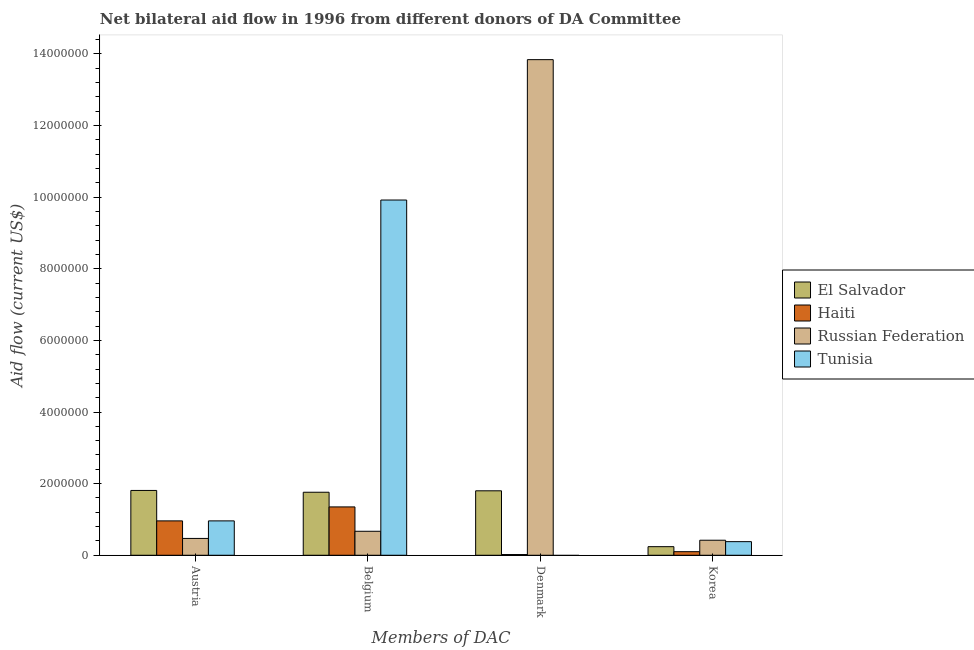What is the amount of aid given by denmark in Haiti?
Your answer should be compact. 2.00e+04. Across all countries, what is the maximum amount of aid given by austria?
Ensure brevity in your answer.  1.81e+06. Across all countries, what is the minimum amount of aid given by belgium?
Offer a very short reply. 6.70e+05. In which country was the amount of aid given by denmark maximum?
Keep it short and to the point. Russian Federation. What is the total amount of aid given by belgium in the graph?
Ensure brevity in your answer.  1.37e+07. What is the difference between the amount of aid given by austria in Haiti and that in El Salvador?
Ensure brevity in your answer.  -8.50e+05. What is the difference between the amount of aid given by korea in Russian Federation and the amount of aid given by austria in El Salvador?
Your response must be concise. -1.39e+06. What is the average amount of aid given by korea per country?
Give a very brief answer. 2.85e+05. What is the difference between the amount of aid given by korea and amount of aid given by austria in El Salvador?
Provide a short and direct response. -1.57e+06. In how many countries, is the amount of aid given by austria greater than 11600000 US$?
Give a very brief answer. 0. What is the ratio of the amount of aid given by belgium in Russian Federation to that in El Salvador?
Keep it short and to the point. 0.38. Is the amount of aid given by austria in El Salvador less than that in Haiti?
Provide a succinct answer. No. Is the difference between the amount of aid given by belgium in Haiti and El Salvador greater than the difference between the amount of aid given by denmark in Haiti and El Salvador?
Your answer should be very brief. Yes. What is the difference between the highest and the second highest amount of aid given by denmark?
Make the answer very short. 1.20e+07. What is the difference between the highest and the lowest amount of aid given by denmark?
Offer a terse response. 1.38e+07. In how many countries, is the amount of aid given by korea greater than the average amount of aid given by korea taken over all countries?
Provide a succinct answer. 2. Is it the case that in every country, the sum of the amount of aid given by denmark and amount of aid given by austria is greater than the sum of amount of aid given by korea and amount of aid given by belgium?
Provide a short and direct response. No. Is it the case that in every country, the sum of the amount of aid given by austria and amount of aid given by belgium is greater than the amount of aid given by denmark?
Your answer should be compact. No. What is the difference between two consecutive major ticks on the Y-axis?
Offer a terse response. 2.00e+06. Does the graph contain any zero values?
Make the answer very short. Yes. What is the title of the graph?
Your answer should be compact. Net bilateral aid flow in 1996 from different donors of DA Committee. Does "Kiribati" appear as one of the legend labels in the graph?
Make the answer very short. No. What is the label or title of the X-axis?
Your response must be concise. Members of DAC. What is the Aid flow (current US$) of El Salvador in Austria?
Provide a short and direct response. 1.81e+06. What is the Aid flow (current US$) in Haiti in Austria?
Offer a very short reply. 9.60e+05. What is the Aid flow (current US$) of Russian Federation in Austria?
Provide a short and direct response. 4.70e+05. What is the Aid flow (current US$) in Tunisia in Austria?
Your answer should be compact. 9.60e+05. What is the Aid flow (current US$) in El Salvador in Belgium?
Provide a short and direct response. 1.76e+06. What is the Aid flow (current US$) in Haiti in Belgium?
Offer a very short reply. 1.35e+06. What is the Aid flow (current US$) of Russian Federation in Belgium?
Offer a terse response. 6.70e+05. What is the Aid flow (current US$) in Tunisia in Belgium?
Your answer should be very brief. 9.92e+06. What is the Aid flow (current US$) of El Salvador in Denmark?
Make the answer very short. 1.80e+06. What is the Aid flow (current US$) of Russian Federation in Denmark?
Make the answer very short. 1.38e+07. What is the Aid flow (current US$) in Russian Federation in Korea?
Offer a terse response. 4.20e+05. What is the Aid flow (current US$) of Tunisia in Korea?
Offer a very short reply. 3.80e+05. Across all Members of DAC, what is the maximum Aid flow (current US$) of El Salvador?
Your answer should be very brief. 1.81e+06. Across all Members of DAC, what is the maximum Aid flow (current US$) in Haiti?
Offer a very short reply. 1.35e+06. Across all Members of DAC, what is the maximum Aid flow (current US$) of Russian Federation?
Make the answer very short. 1.38e+07. Across all Members of DAC, what is the maximum Aid flow (current US$) in Tunisia?
Make the answer very short. 9.92e+06. What is the total Aid flow (current US$) of El Salvador in the graph?
Provide a short and direct response. 5.61e+06. What is the total Aid flow (current US$) in Haiti in the graph?
Keep it short and to the point. 2.43e+06. What is the total Aid flow (current US$) of Russian Federation in the graph?
Provide a short and direct response. 1.54e+07. What is the total Aid flow (current US$) in Tunisia in the graph?
Provide a succinct answer. 1.13e+07. What is the difference between the Aid flow (current US$) in El Salvador in Austria and that in Belgium?
Provide a short and direct response. 5.00e+04. What is the difference between the Aid flow (current US$) of Haiti in Austria and that in Belgium?
Make the answer very short. -3.90e+05. What is the difference between the Aid flow (current US$) in Tunisia in Austria and that in Belgium?
Give a very brief answer. -8.96e+06. What is the difference between the Aid flow (current US$) in El Salvador in Austria and that in Denmark?
Keep it short and to the point. 10000. What is the difference between the Aid flow (current US$) of Haiti in Austria and that in Denmark?
Provide a succinct answer. 9.40e+05. What is the difference between the Aid flow (current US$) in Russian Federation in Austria and that in Denmark?
Your response must be concise. -1.34e+07. What is the difference between the Aid flow (current US$) of El Salvador in Austria and that in Korea?
Give a very brief answer. 1.57e+06. What is the difference between the Aid flow (current US$) in Haiti in Austria and that in Korea?
Provide a short and direct response. 8.60e+05. What is the difference between the Aid flow (current US$) in Tunisia in Austria and that in Korea?
Your response must be concise. 5.80e+05. What is the difference between the Aid flow (current US$) in Haiti in Belgium and that in Denmark?
Offer a very short reply. 1.33e+06. What is the difference between the Aid flow (current US$) of Russian Federation in Belgium and that in Denmark?
Provide a succinct answer. -1.32e+07. What is the difference between the Aid flow (current US$) in El Salvador in Belgium and that in Korea?
Your answer should be very brief. 1.52e+06. What is the difference between the Aid flow (current US$) in Haiti in Belgium and that in Korea?
Your answer should be compact. 1.25e+06. What is the difference between the Aid flow (current US$) of Russian Federation in Belgium and that in Korea?
Your answer should be compact. 2.50e+05. What is the difference between the Aid flow (current US$) in Tunisia in Belgium and that in Korea?
Keep it short and to the point. 9.54e+06. What is the difference between the Aid flow (current US$) of El Salvador in Denmark and that in Korea?
Keep it short and to the point. 1.56e+06. What is the difference between the Aid flow (current US$) in Haiti in Denmark and that in Korea?
Your answer should be compact. -8.00e+04. What is the difference between the Aid flow (current US$) in Russian Federation in Denmark and that in Korea?
Give a very brief answer. 1.34e+07. What is the difference between the Aid flow (current US$) in El Salvador in Austria and the Aid flow (current US$) in Haiti in Belgium?
Provide a short and direct response. 4.60e+05. What is the difference between the Aid flow (current US$) of El Salvador in Austria and the Aid flow (current US$) of Russian Federation in Belgium?
Your answer should be compact. 1.14e+06. What is the difference between the Aid flow (current US$) of El Salvador in Austria and the Aid flow (current US$) of Tunisia in Belgium?
Provide a short and direct response. -8.11e+06. What is the difference between the Aid flow (current US$) of Haiti in Austria and the Aid flow (current US$) of Tunisia in Belgium?
Ensure brevity in your answer.  -8.96e+06. What is the difference between the Aid flow (current US$) in Russian Federation in Austria and the Aid flow (current US$) in Tunisia in Belgium?
Your answer should be very brief. -9.45e+06. What is the difference between the Aid flow (current US$) in El Salvador in Austria and the Aid flow (current US$) in Haiti in Denmark?
Offer a very short reply. 1.79e+06. What is the difference between the Aid flow (current US$) in El Salvador in Austria and the Aid flow (current US$) in Russian Federation in Denmark?
Provide a short and direct response. -1.20e+07. What is the difference between the Aid flow (current US$) in Haiti in Austria and the Aid flow (current US$) in Russian Federation in Denmark?
Your answer should be compact. -1.29e+07. What is the difference between the Aid flow (current US$) in El Salvador in Austria and the Aid flow (current US$) in Haiti in Korea?
Your answer should be compact. 1.71e+06. What is the difference between the Aid flow (current US$) of El Salvador in Austria and the Aid flow (current US$) of Russian Federation in Korea?
Your answer should be compact. 1.39e+06. What is the difference between the Aid flow (current US$) of El Salvador in Austria and the Aid flow (current US$) of Tunisia in Korea?
Your answer should be very brief. 1.43e+06. What is the difference between the Aid flow (current US$) of Haiti in Austria and the Aid flow (current US$) of Russian Federation in Korea?
Give a very brief answer. 5.40e+05. What is the difference between the Aid flow (current US$) in Haiti in Austria and the Aid flow (current US$) in Tunisia in Korea?
Ensure brevity in your answer.  5.80e+05. What is the difference between the Aid flow (current US$) of El Salvador in Belgium and the Aid flow (current US$) of Haiti in Denmark?
Give a very brief answer. 1.74e+06. What is the difference between the Aid flow (current US$) in El Salvador in Belgium and the Aid flow (current US$) in Russian Federation in Denmark?
Keep it short and to the point. -1.21e+07. What is the difference between the Aid flow (current US$) of Haiti in Belgium and the Aid flow (current US$) of Russian Federation in Denmark?
Make the answer very short. -1.25e+07. What is the difference between the Aid flow (current US$) in El Salvador in Belgium and the Aid flow (current US$) in Haiti in Korea?
Offer a very short reply. 1.66e+06. What is the difference between the Aid flow (current US$) of El Salvador in Belgium and the Aid flow (current US$) of Russian Federation in Korea?
Your response must be concise. 1.34e+06. What is the difference between the Aid flow (current US$) in El Salvador in Belgium and the Aid flow (current US$) in Tunisia in Korea?
Your answer should be very brief. 1.38e+06. What is the difference between the Aid flow (current US$) in Haiti in Belgium and the Aid flow (current US$) in Russian Federation in Korea?
Keep it short and to the point. 9.30e+05. What is the difference between the Aid flow (current US$) of Haiti in Belgium and the Aid flow (current US$) of Tunisia in Korea?
Keep it short and to the point. 9.70e+05. What is the difference between the Aid flow (current US$) in El Salvador in Denmark and the Aid flow (current US$) in Haiti in Korea?
Ensure brevity in your answer.  1.70e+06. What is the difference between the Aid flow (current US$) in El Salvador in Denmark and the Aid flow (current US$) in Russian Federation in Korea?
Your answer should be compact. 1.38e+06. What is the difference between the Aid flow (current US$) in El Salvador in Denmark and the Aid flow (current US$) in Tunisia in Korea?
Your response must be concise. 1.42e+06. What is the difference between the Aid flow (current US$) of Haiti in Denmark and the Aid flow (current US$) of Russian Federation in Korea?
Provide a succinct answer. -4.00e+05. What is the difference between the Aid flow (current US$) in Haiti in Denmark and the Aid flow (current US$) in Tunisia in Korea?
Make the answer very short. -3.60e+05. What is the difference between the Aid flow (current US$) in Russian Federation in Denmark and the Aid flow (current US$) in Tunisia in Korea?
Provide a short and direct response. 1.35e+07. What is the average Aid flow (current US$) in El Salvador per Members of DAC?
Make the answer very short. 1.40e+06. What is the average Aid flow (current US$) of Haiti per Members of DAC?
Make the answer very short. 6.08e+05. What is the average Aid flow (current US$) in Russian Federation per Members of DAC?
Provide a short and direct response. 3.85e+06. What is the average Aid flow (current US$) of Tunisia per Members of DAC?
Your answer should be very brief. 2.82e+06. What is the difference between the Aid flow (current US$) in El Salvador and Aid flow (current US$) in Haiti in Austria?
Your response must be concise. 8.50e+05. What is the difference between the Aid flow (current US$) in El Salvador and Aid flow (current US$) in Russian Federation in Austria?
Offer a very short reply. 1.34e+06. What is the difference between the Aid flow (current US$) of El Salvador and Aid flow (current US$) of Tunisia in Austria?
Give a very brief answer. 8.50e+05. What is the difference between the Aid flow (current US$) of Haiti and Aid flow (current US$) of Tunisia in Austria?
Provide a short and direct response. 0. What is the difference between the Aid flow (current US$) of Russian Federation and Aid flow (current US$) of Tunisia in Austria?
Your response must be concise. -4.90e+05. What is the difference between the Aid flow (current US$) of El Salvador and Aid flow (current US$) of Haiti in Belgium?
Offer a very short reply. 4.10e+05. What is the difference between the Aid flow (current US$) in El Salvador and Aid flow (current US$) in Russian Federation in Belgium?
Provide a succinct answer. 1.09e+06. What is the difference between the Aid flow (current US$) in El Salvador and Aid flow (current US$) in Tunisia in Belgium?
Offer a terse response. -8.16e+06. What is the difference between the Aid flow (current US$) in Haiti and Aid flow (current US$) in Russian Federation in Belgium?
Give a very brief answer. 6.80e+05. What is the difference between the Aid flow (current US$) of Haiti and Aid flow (current US$) of Tunisia in Belgium?
Provide a short and direct response. -8.57e+06. What is the difference between the Aid flow (current US$) in Russian Federation and Aid flow (current US$) in Tunisia in Belgium?
Offer a very short reply. -9.25e+06. What is the difference between the Aid flow (current US$) of El Salvador and Aid flow (current US$) of Haiti in Denmark?
Provide a succinct answer. 1.78e+06. What is the difference between the Aid flow (current US$) in El Salvador and Aid flow (current US$) in Russian Federation in Denmark?
Provide a short and direct response. -1.20e+07. What is the difference between the Aid flow (current US$) in Haiti and Aid flow (current US$) in Russian Federation in Denmark?
Your answer should be compact. -1.38e+07. What is the difference between the Aid flow (current US$) of El Salvador and Aid flow (current US$) of Russian Federation in Korea?
Offer a very short reply. -1.80e+05. What is the difference between the Aid flow (current US$) of Haiti and Aid flow (current US$) of Russian Federation in Korea?
Give a very brief answer. -3.20e+05. What is the difference between the Aid flow (current US$) in Haiti and Aid flow (current US$) in Tunisia in Korea?
Provide a succinct answer. -2.80e+05. What is the ratio of the Aid flow (current US$) of El Salvador in Austria to that in Belgium?
Provide a succinct answer. 1.03. What is the ratio of the Aid flow (current US$) of Haiti in Austria to that in Belgium?
Provide a succinct answer. 0.71. What is the ratio of the Aid flow (current US$) of Russian Federation in Austria to that in Belgium?
Give a very brief answer. 0.7. What is the ratio of the Aid flow (current US$) in Tunisia in Austria to that in Belgium?
Ensure brevity in your answer.  0.1. What is the ratio of the Aid flow (current US$) of El Salvador in Austria to that in Denmark?
Your answer should be compact. 1.01. What is the ratio of the Aid flow (current US$) of Haiti in Austria to that in Denmark?
Offer a terse response. 48. What is the ratio of the Aid flow (current US$) of Russian Federation in Austria to that in Denmark?
Offer a terse response. 0.03. What is the ratio of the Aid flow (current US$) in El Salvador in Austria to that in Korea?
Keep it short and to the point. 7.54. What is the ratio of the Aid flow (current US$) in Russian Federation in Austria to that in Korea?
Your response must be concise. 1.12. What is the ratio of the Aid flow (current US$) in Tunisia in Austria to that in Korea?
Your response must be concise. 2.53. What is the ratio of the Aid flow (current US$) of El Salvador in Belgium to that in Denmark?
Your answer should be compact. 0.98. What is the ratio of the Aid flow (current US$) in Haiti in Belgium to that in Denmark?
Your response must be concise. 67.5. What is the ratio of the Aid flow (current US$) in Russian Federation in Belgium to that in Denmark?
Give a very brief answer. 0.05. What is the ratio of the Aid flow (current US$) of El Salvador in Belgium to that in Korea?
Give a very brief answer. 7.33. What is the ratio of the Aid flow (current US$) in Haiti in Belgium to that in Korea?
Your answer should be very brief. 13.5. What is the ratio of the Aid flow (current US$) of Russian Federation in Belgium to that in Korea?
Your response must be concise. 1.6. What is the ratio of the Aid flow (current US$) in Tunisia in Belgium to that in Korea?
Give a very brief answer. 26.11. What is the ratio of the Aid flow (current US$) of El Salvador in Denmark to that in Korea?
Ensure brevity in your answer.  7.5. What is the ratio of the Aid flow (current US$) of Russian Federation in Denmark to that in Korea?
Provide a succinct answer. 32.95. What is the difference between the highest and the second highest Aid flow (current US$) of Haiti?
Offer a terse response. 3.90e+05. What is the difference between the highest and the second highest Aid flow (current US$) in Russian Federation?
Keep it short and to the point. 1.32e+07. What is the difference between the highest and the second highest Aid flow (current US$) in Tunisia?
Offer a very short reply. 8.96e+06. What is the difference between the highest and the lowest Aid flow (current US$) of El Salvador?
Offer a terse response. 1.57e+06. What is the difference between the highest and the lowest Aid flow (current US$) of Haiti?
Offer a terse response. 1.33e+06. What is the difference between the highest and the lowest Aid flow (current US$) in Russian Federation?
Make the answer very short. 1.34e+07. What is the difference between the highest and the lowest Aid flow (current US$) of Tunisia?
Your answer should be compact. 9.92e+06. 